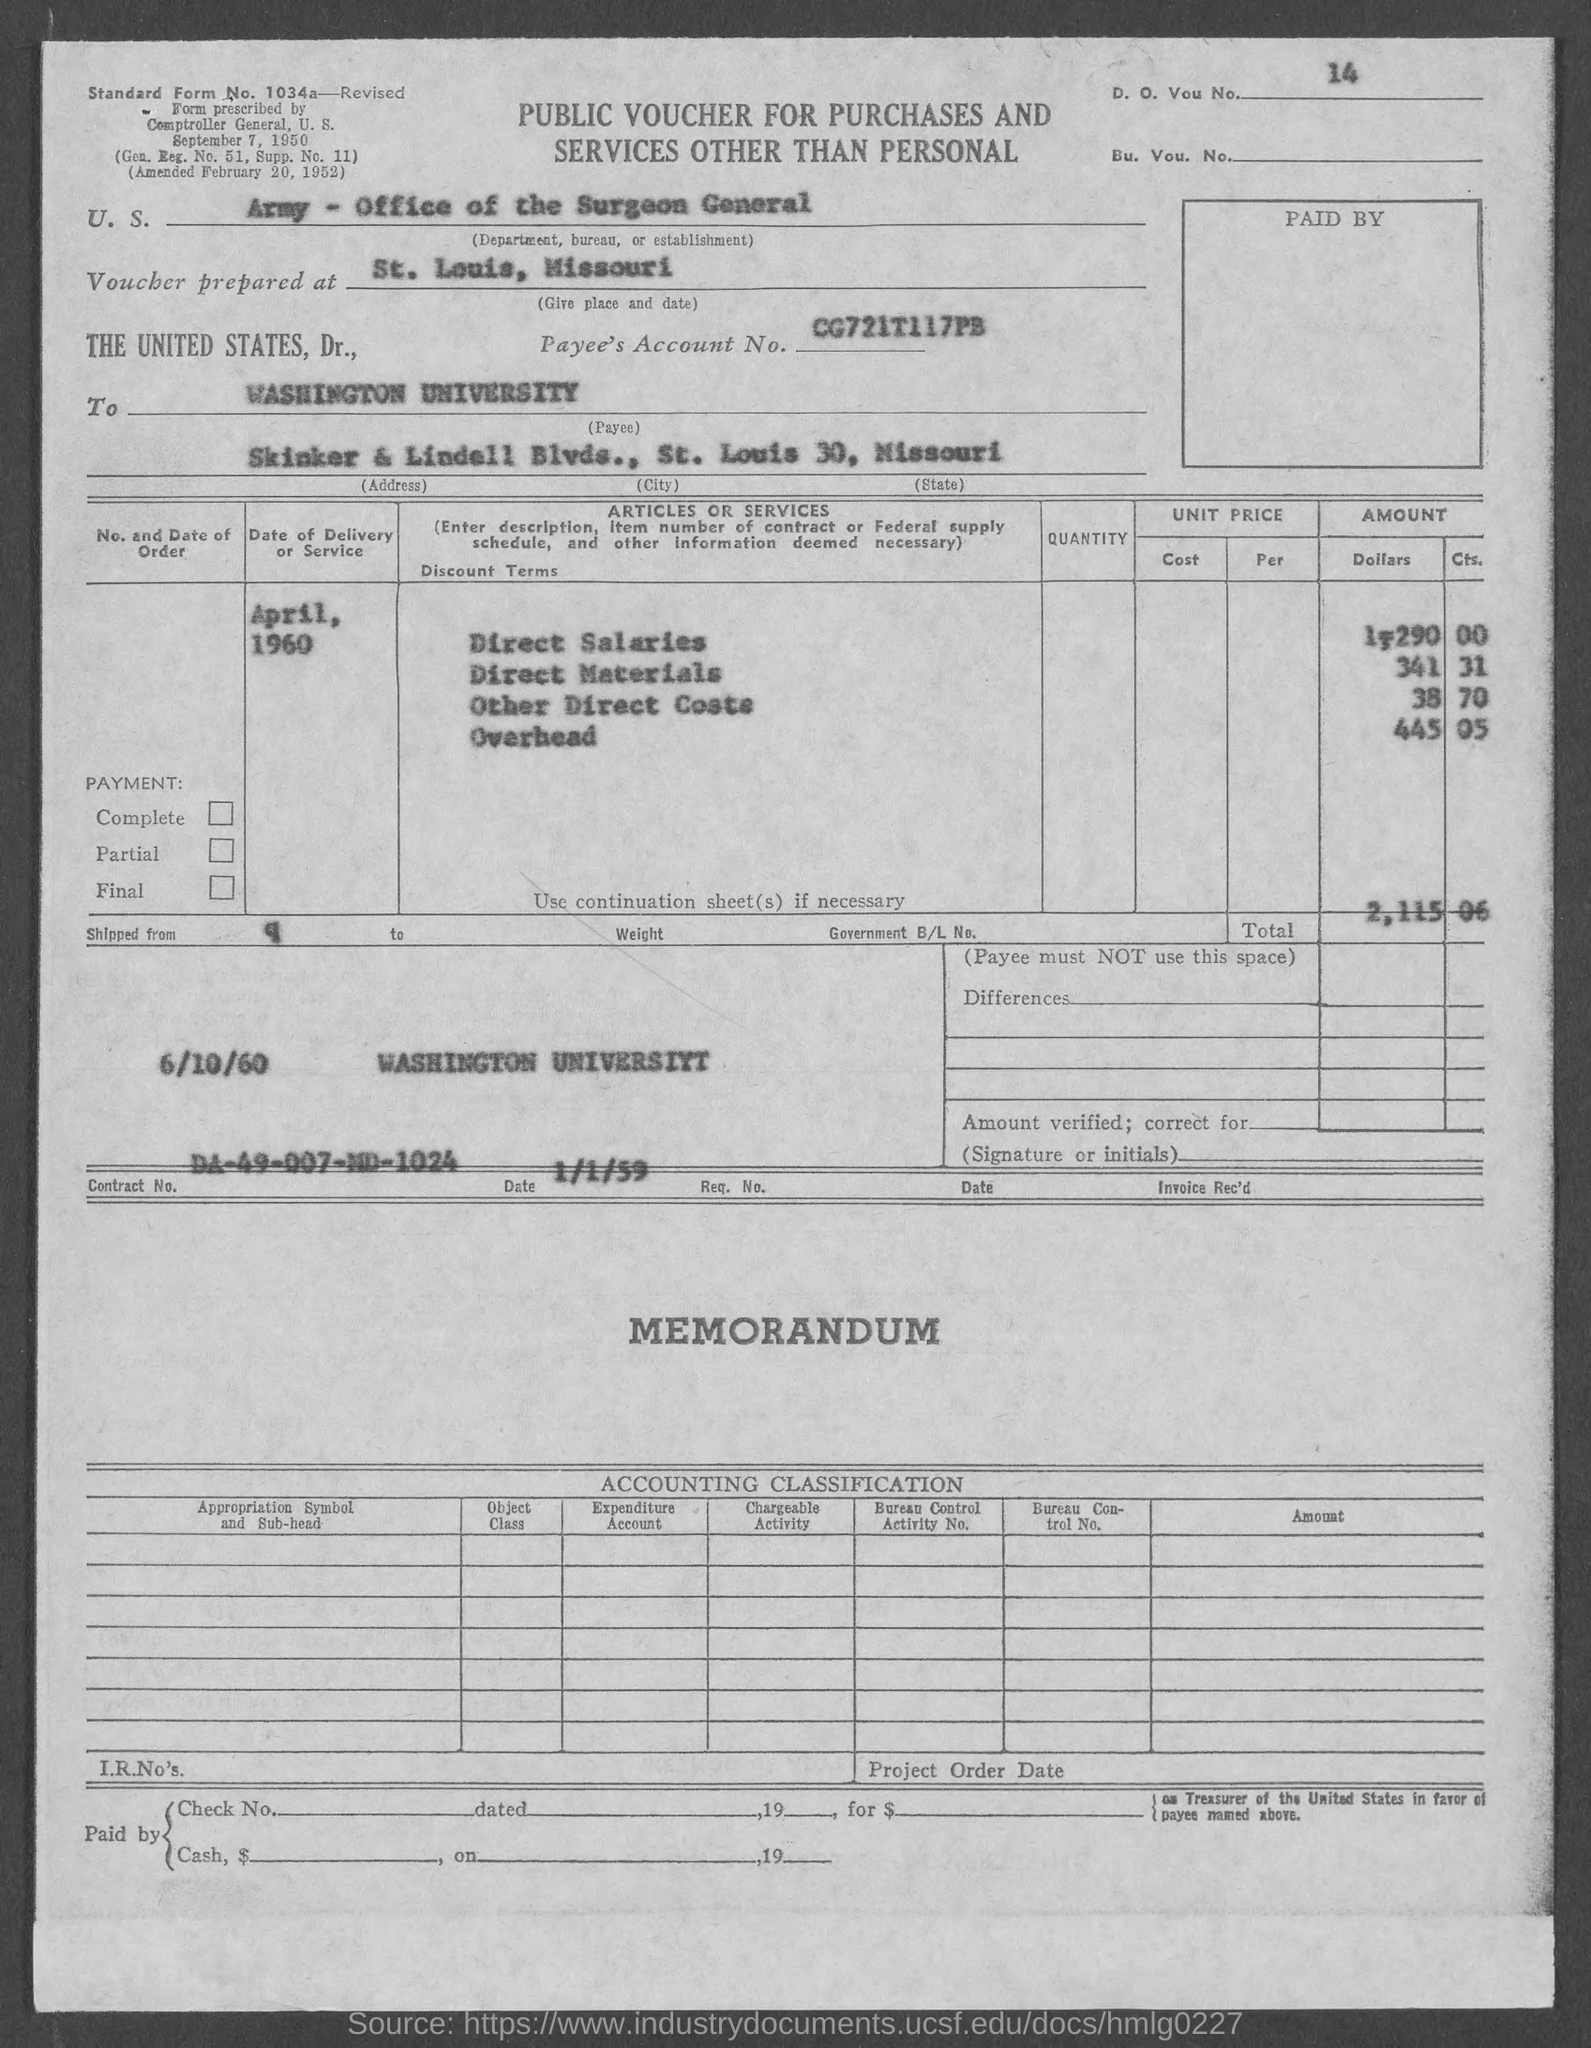What is the D. O. Vou. No. given in the voucher?
Your response must be concise. 14. Where is the voucher prepared at?
Give a very brief answer. St. Louis, Missouri. What is the Payee's Account No. given in the voucher?
Offer a very short reply. CG721T117PB. What is the Payee name given in the voucher?
Your answer should be very brief. WASHINGTON UNIVERSITY. What is the Contract No. given in the voucher?
Give a very brief answer. DA-49-007-MD-1024. What is the date of delivery of service mentioned in the voucher?
Ensure brevity in your answer.  April, 1960. 